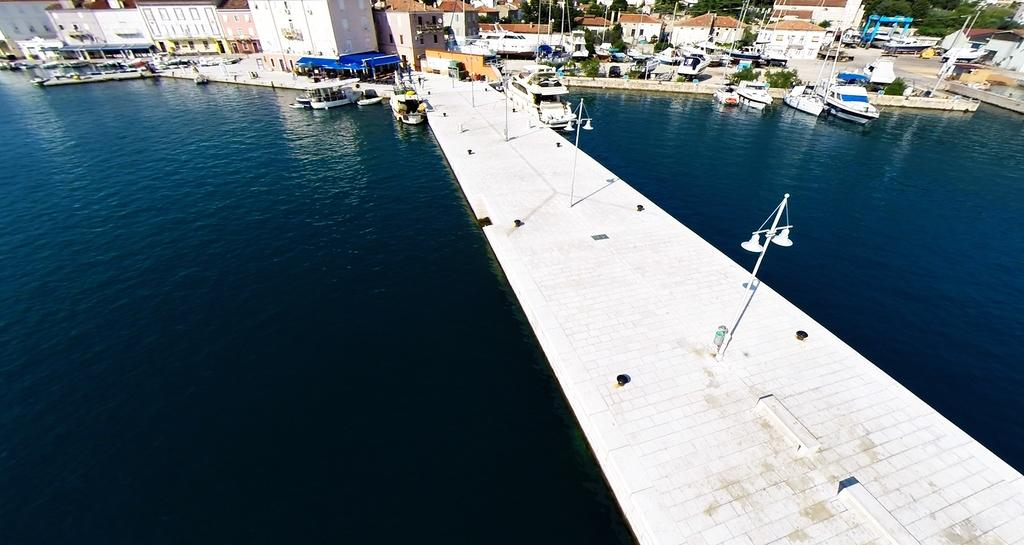What types of vehicles are in the image? There are boats and ships in the image. Where are the boats and ships located in relation to the water? The boats and ships are above the water. What can be seen on the poles in the image? There are lights on poles in the image. What is visible in the background of the image? There are buildings and trees in the background of the image. How does the mother communicate with the boats and ships in the image? There is no mention of a mother in the image, so it is not possible to answer that question. 